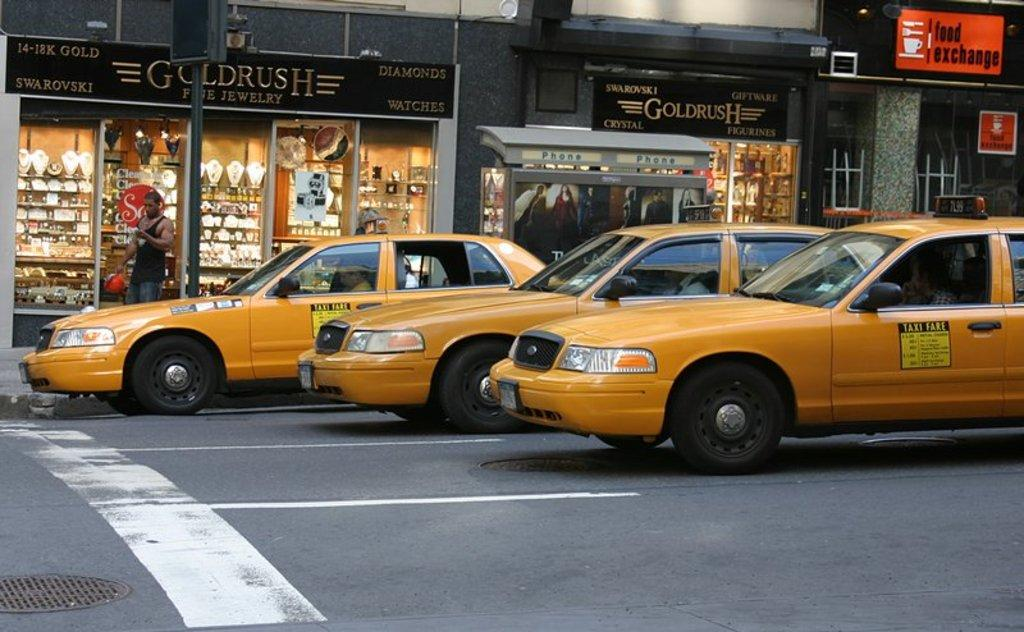Provide a one-sentence caption for the provided image. Taxis have their fare on the side so people can estimate how expensive the trip will be. 